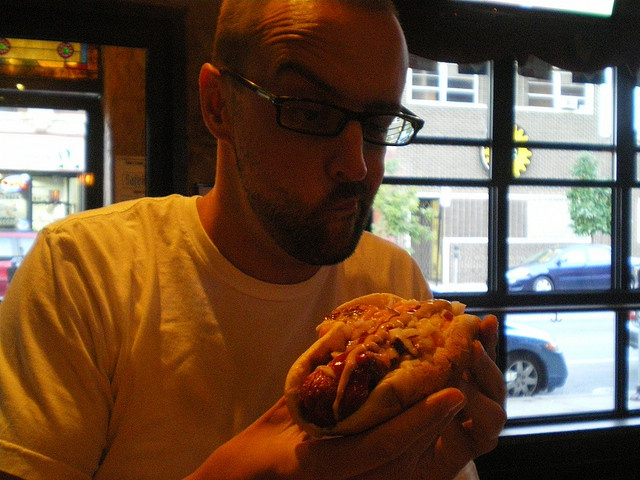Describe the objects in this image and their specific colors. I can see people in black, maroon, and brown tones, hot dog in black, maroon, and red tones, car in black, white, blue, gray, and lightblue tones, car in black, gray, white, and darkgray tones, and car in black, lavender, lightblue, brown, and gray tones in this image. 